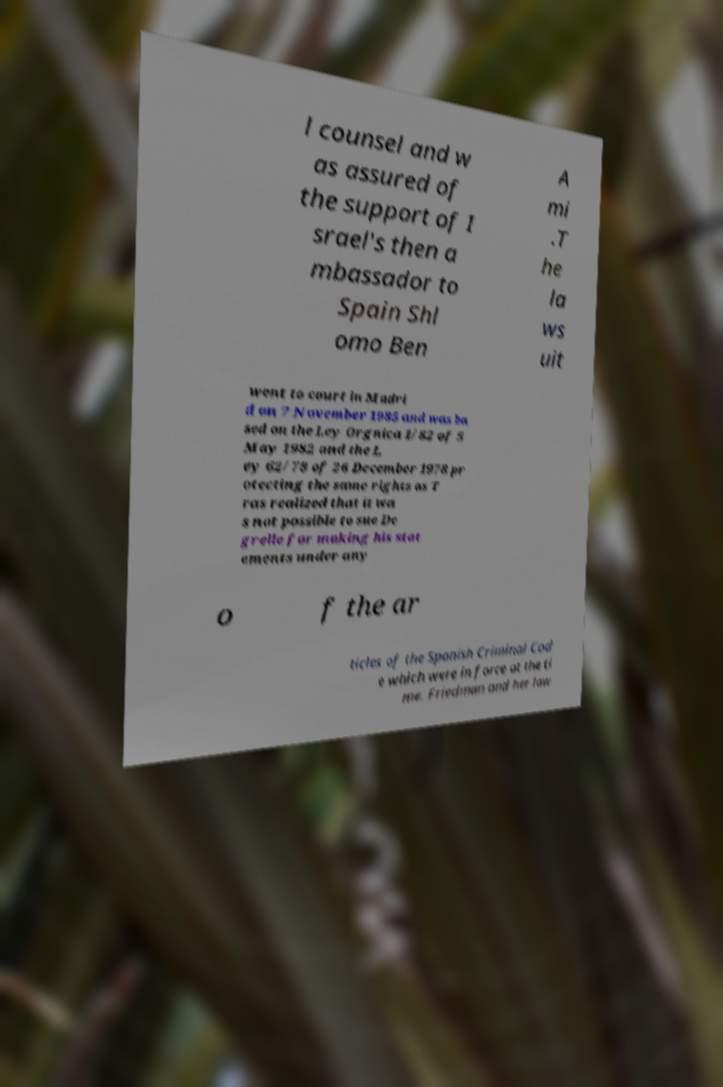I need the written content from this picture converted into text. Can you do that? l counsel and w as assured of the support of I srael's then a mbassador to Spain Shl omo Ben A mi .T he la ws uit went to court in Madri d on 7 November 1985 and was ba sed on the Ley Orgnica 1/82 of 5 May 1982 and the L ey 62/78 of 26 December 1978 pr otecting the same rights as T ras realized that it wa s not possible to sue De grelle for making his stat ements under any o f the ar ticles of the Spanish Criminal Cod e which were in force at the ti me. Friedman and her law 